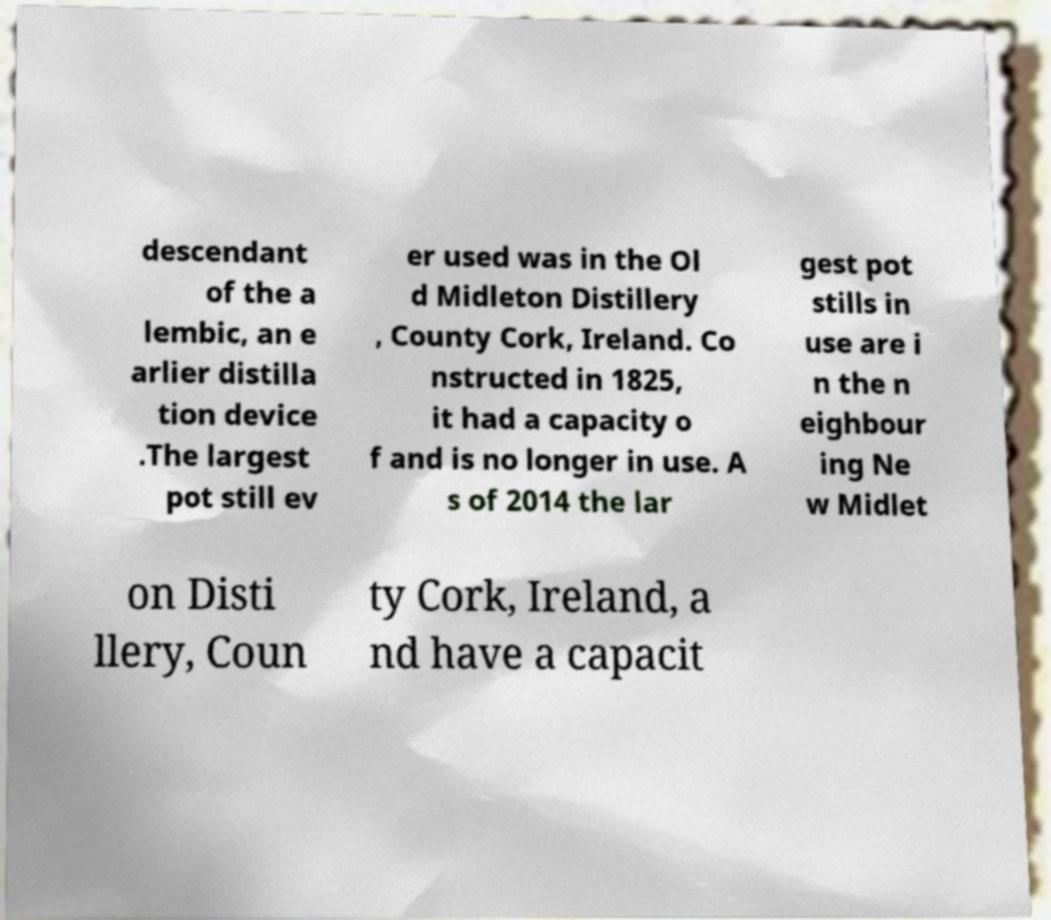For documentation purposes, I need the text within this image transcribed. Could you provide that? descendant of the a lembic, an e arlier distilla tion device .The largest pot still ev er used was in the Ol d Midleton Distillery , County Cork, Ireland. Co nstructed in 1825, it had a capacity o f and is no longer in use. A s of 2014 the lar gest pot stills in use are i n the n eighbour ing Ne w Midlet on Disti llery, Coun ty Cork, Ireland, a nd have a capacit 